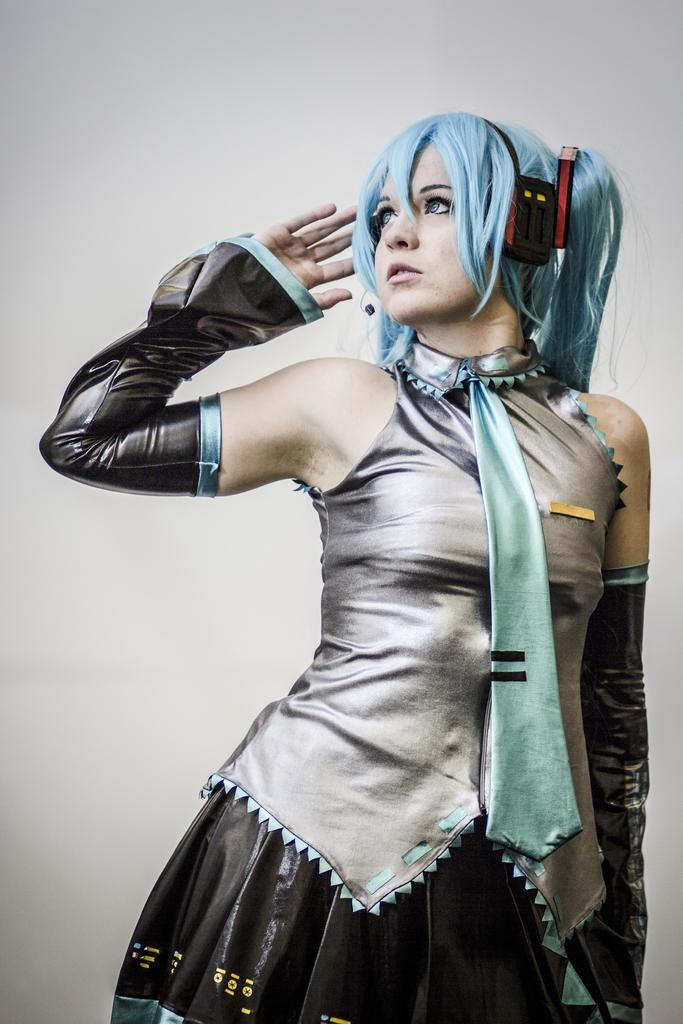What is the main subject of the image? The main subject of the image is a picture of a girl. What is the girl wearing in the image? The girl is wearing a silver color costume. Are there any accessories visible in the image? Yes, the girl is wearing headphones. Can you describe any other details about the girl's appearance? There is a blue color tie around her neck. What type of line is the girl holding in the image? There is no line present in the image. Can you see any flames around the girl in the image? No, there are no flames visible in the image. 